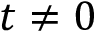Convert formula to latex. <formula><loc_0><loc_0><loc_500><loc_500>t \neq 0</formula> 